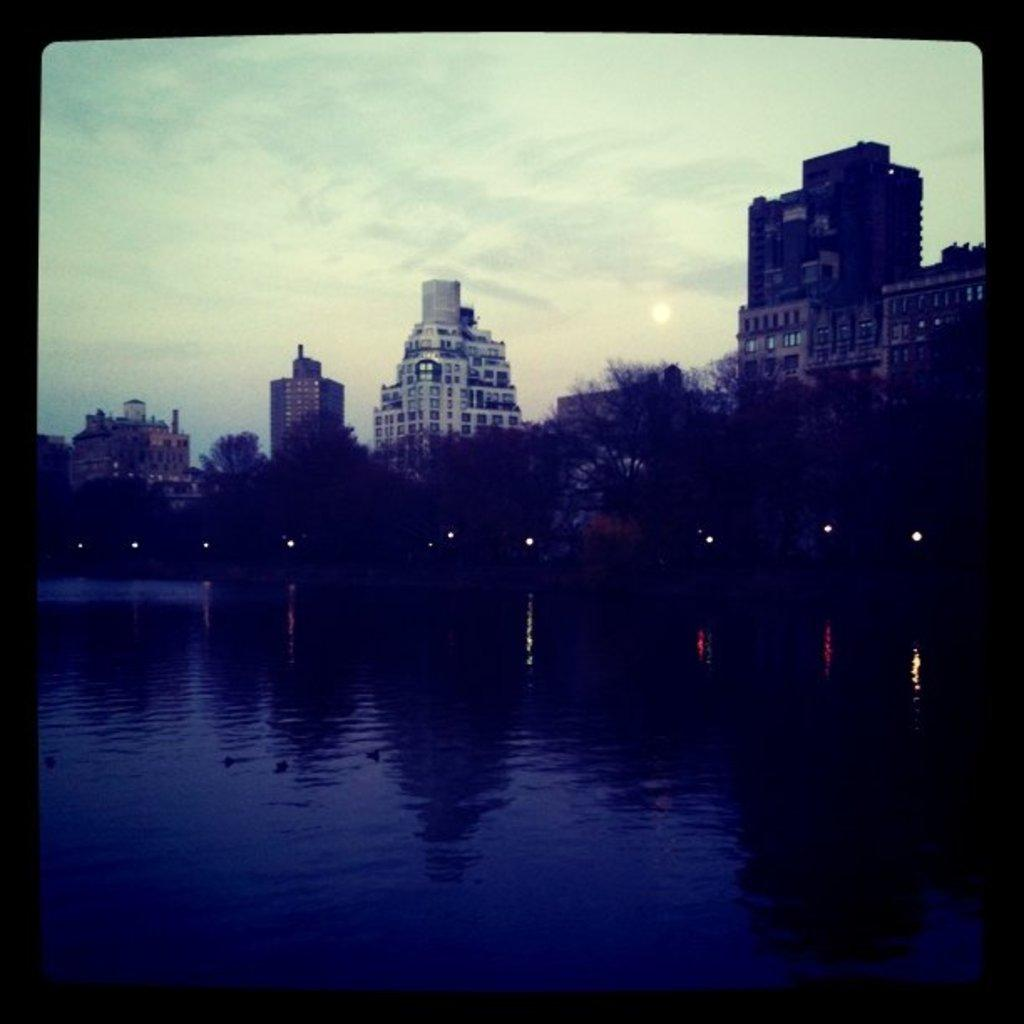What is in the water in the image? There are objects in the water in the image. What can be seen in the background of the image? There are lights, trees, and buildings in the background of the image. What is visible at the top of the image? The sky is visible at the top of the image. How many snails are crawling on the buildings in the image? There are no snails present in the image; it features objects in the water and various elements in the background. 